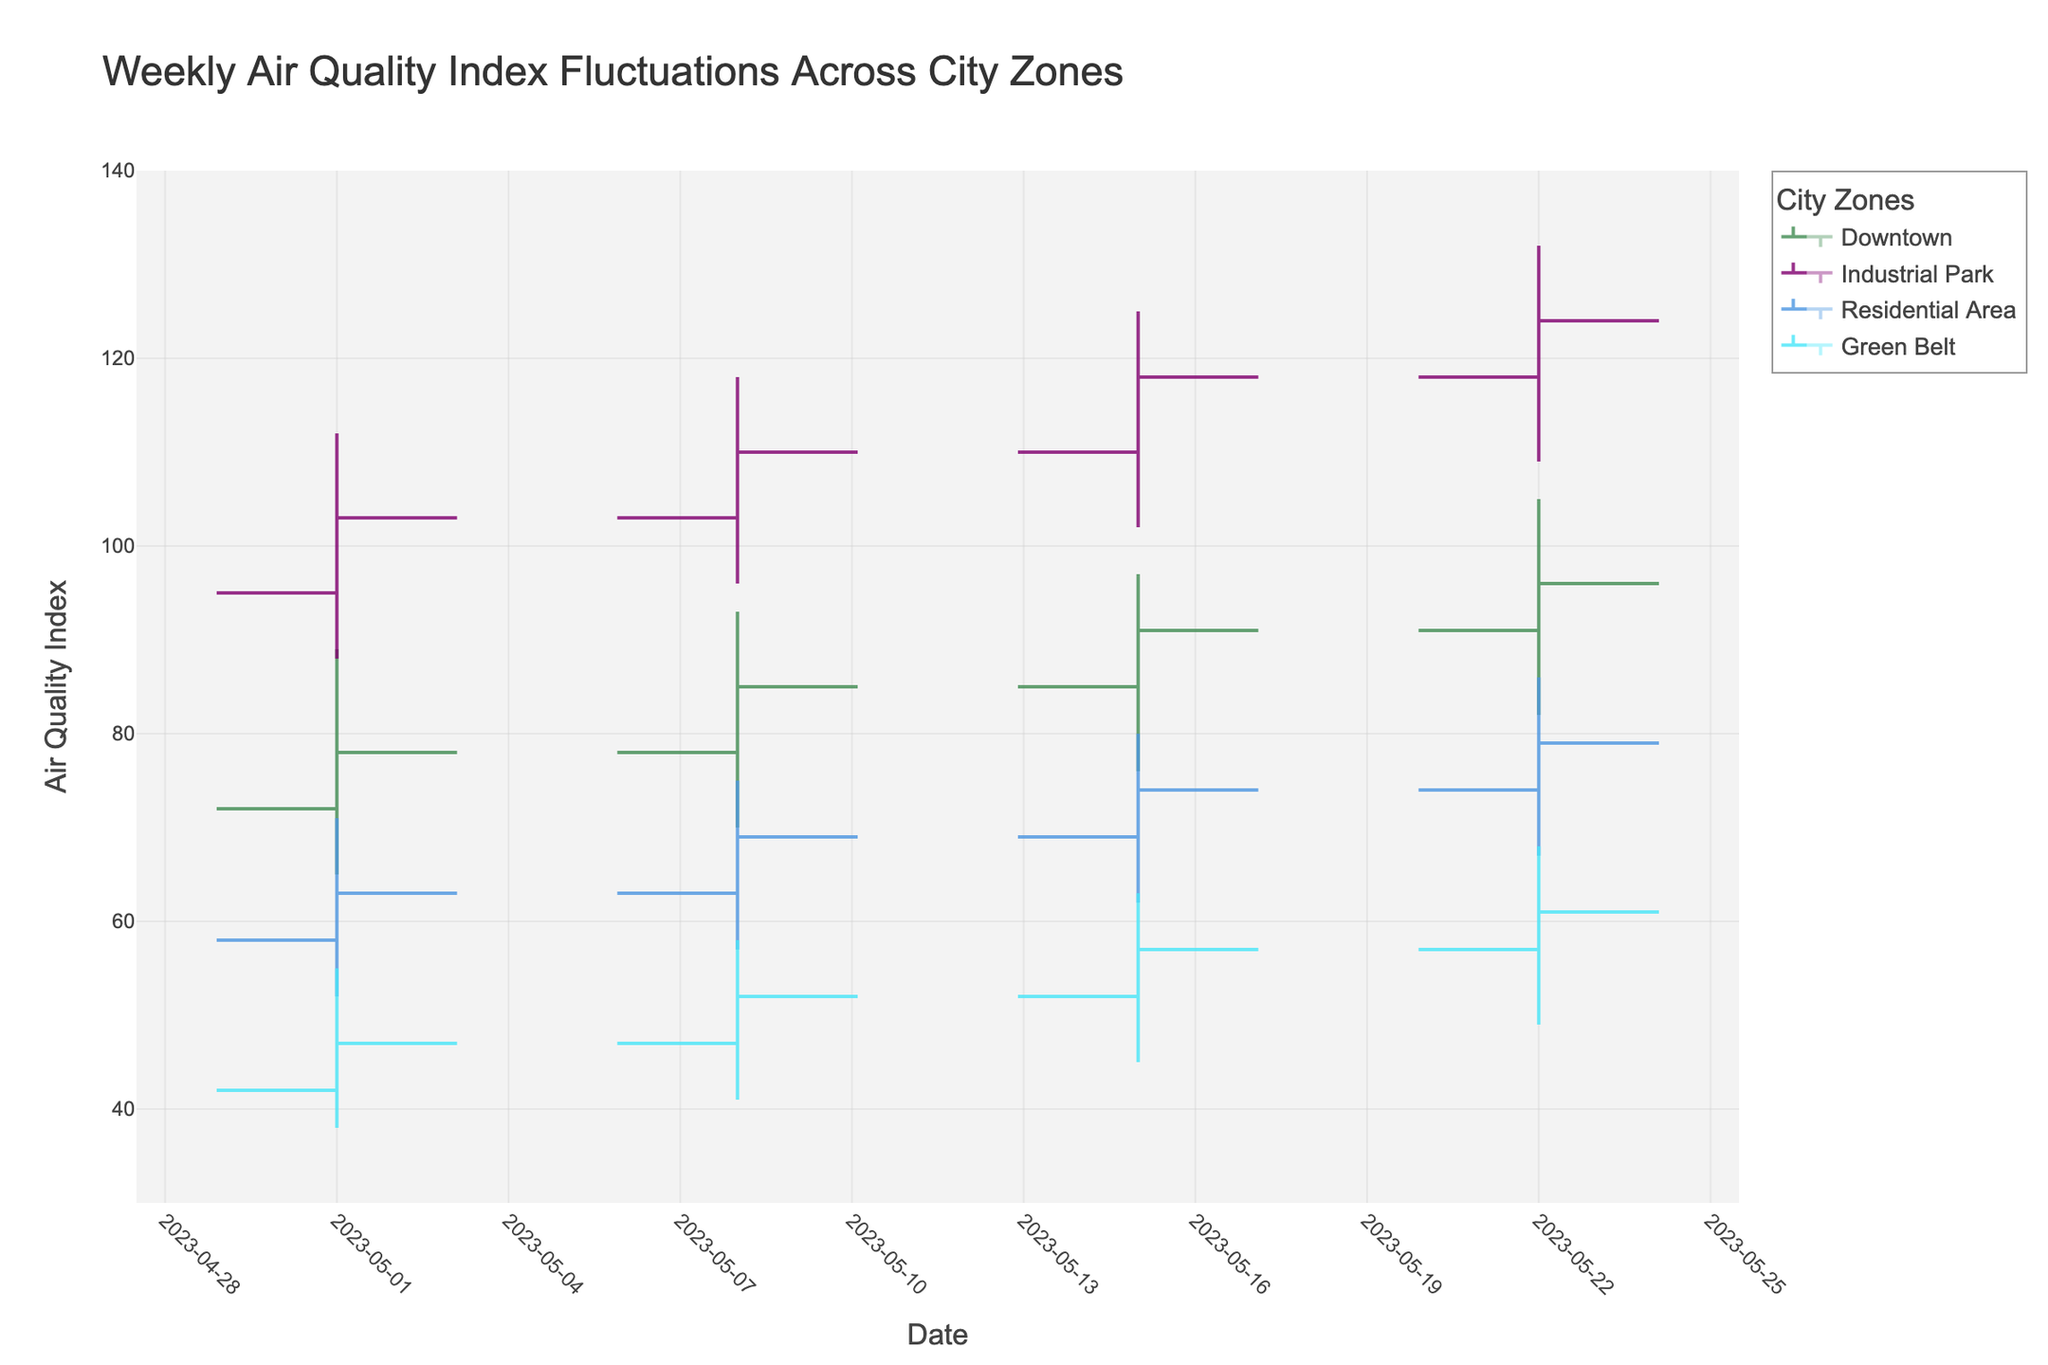What is the title of the figure? The title of the figure is displayed prominently at the top and reads "Weekly Air Quality Index Fluctuations Across City Zones".
Answer: Weekly Air Quality Index Fluctuations Across City Zones What does the X-axis represent? The X-axis represents the dates recorded weekly from May 1, 2023, onward.
Answer: Date Which zone had the highest Air Quality Index on May 15, 2023? Look for the bar on May 15, 2023, and then identify the zone with the highest "High" value. The zone with the highest peak is the Industrial Park with a value of 125.
Answer: Industrial Park What is the trend of the Air Quality Index for the Downtown zone over these weeks? Observe the OHLC data for Downtown across the dates. From May 1 to May 22, the overall trend is an increase starting from 72 (Open on May 1) to 96 (Close on May 22). Details of the increase can be seen by examining the Close values for each week (78 to 85 to 91 to 96).
Answer: Increasing Which zone showed the smallest range of AQI on May 8, 2023? The range can be determined by subtracting the Low value from the High value for each zone on May 8, 2023. Downtown (93-70=23), Industrial Park (118-96=22), Residential Area (75-57=18), Green Belt (58-41=17). The Green Belt has the smallest range.
Answer: Green Belt By how much did the AQI for Industrial Park increase from May 1, 2023, to May 15, 2023? Determine the increase from the Close value on May 1 (103) to the Close value on May 15 (118). The difference is 118 - 103.
Answer: 15 How does the AQI of the Residential Area compare from May 8 to May 15 in terms of the closing values? Check the close values for the Residential Area on May 8 (69) and May 15 (74). The close value increased from 69 to 74.
Answer: Increased Which zone showed the largest variability in AQI throughout the entire period? Variability can be assessed by comparing the ranges (High - Low) for each zone over all weeks. Industrial Park has consistently large ranges (112-88, 118-96, 125-102, 132-109).
Answer: Industrial Park What is the average closing AQI for the Green Belt over the recorded weeks? Calculate the average of the Closing values of Green Belt: (47 + 52 + 57 + 61)/4. Sum: 217, Average: 217/4.
Answer: 54.25 